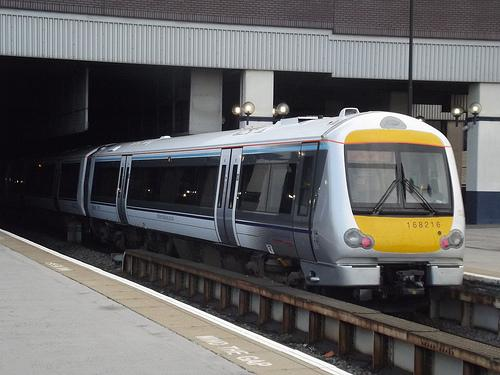Describe the lighting and architecture at the train station. The station has street lamps and lights over the platform, brown brick surface, cement pillars, and a metal pipe attached to the building. Mention the text written in the image and where can it be found. The image has white writing on the train platform and black numbers on the yellow front of the train. Briefly mention the primary object in the image and its current activity. A train is exiting a large building, possibly a tunnel, moving on rusty tracks with gravel surrounding it. Discuss the various doors and windows on the train. Doors of the train are silver, with a double door and a single door near the front, while the passenger windows have a window tint. What can you see about the platform beside the train tracks? The cement platform next to the train tracks has white lettering, grey concrete surface, and a white stripe on the edge. Describe the landscape and the surface around the train tracks. There is loose gravel around the track, and the platform has tan concrete dividers and cement surface. Make an observation about the color and distinctive features of the train in the image. The train is mostly grey with a yellow face, blue stripes on the side, headlights, red lights and windshield wipers. Provide a description of the train's windshield and what is attached to it. The front windshield of the train is large, and it has a pair of windshield wipers. What type of safety features can be seen in the image? The safety features include a warning barrier beside the track and a sidewalk for passengers to wait. Give an overview of the train's front appearance including its lights and colors. The train's front is white and yellow, with red lights, white headlights, and black numbers on the yellow face. 